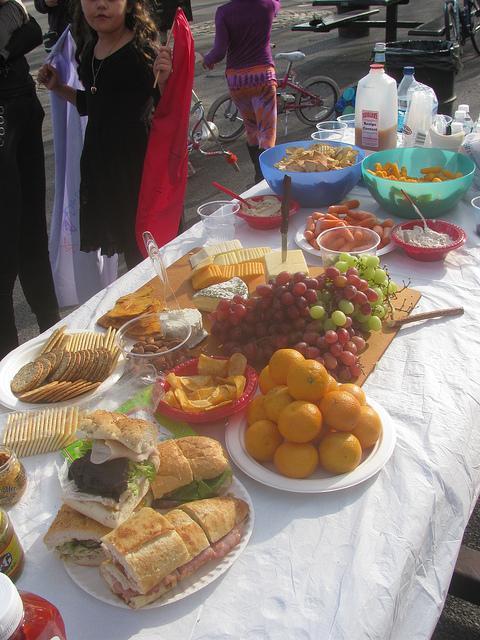How many people can be seen?
Give a very brief answer. 3. How many oranges are in the picture?
Give a very brief answer. 1. How many sandwiches are there?
Give a very brief answer. 2. How many bowls are in the photo?
Give a very brief answer. 3. How many cats are in the picture?
Give a very brief answer. 0. 